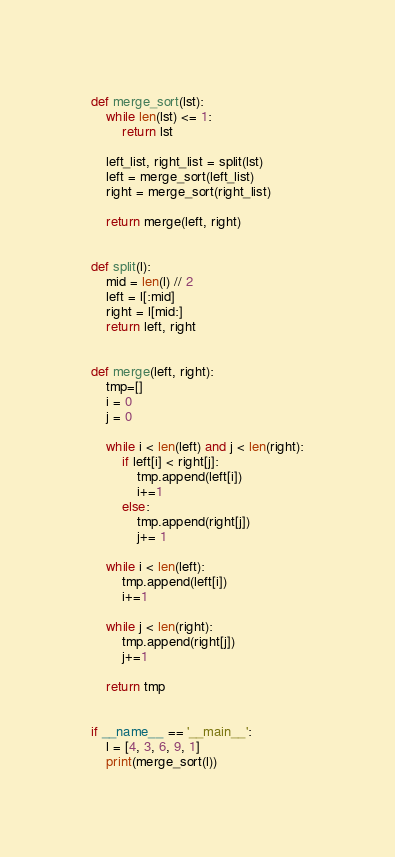Convert code to text. <code><loc_0><loc_0><loc_500><loc_500><_Python_>def merge_sort(lst):
    while len(lst) <= 1:
        return lst

    left_list, right_list = split(lst)
    left = merge_sort(left_list)
    right = merge_sort(right_list)

    return merge(left, right)


def split(l):
    mid = len(l) // 2
    left = l[:mid]
    right = l[mid:]
    return left, right


def merge(left, right):
    tmp=[]
    i = 0
    j = 0

    while i < len(left) and j < len(right):
        if left[i] < right[j]:
            tmp.append(left[i])
            i+=1
        else:
            tmp.append(right[j])
            j+= 1

    while i < len(left):
        tmp.append(left[i])
        i+=1

    while j < len(right):
        tmp.append(right[j])
        j+=1

    return tmp


if __name__ == '__main__':
    l = [4, 3, 6, 9, 1]
    print(merge_sort(l))
</code> 